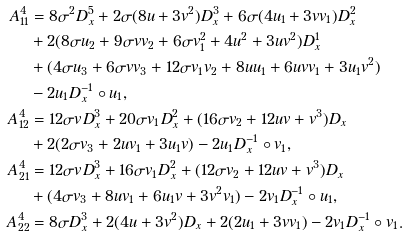<formula> <loc_0><loc_0><loc_500><loc_500>A ^ { 4 } _ { 1 1 } & = 8 \sigma ^ { 2 } D _ { x } ^ { 5 } + 2 \sigma ( 8 u + 3 v ^ { 2 } ) D _ { x } ^ { 3 } + 6 \sigma ( 4 u _ { 1 } + 3 v v _ { 1 } ) D _ { x } ^ { 2 } \\ & + 2 ( 8 \sigma u _ { 2 } + 9 \sigma v v _ { 2 } + 6 \sigma v _ { 1 } ^ { 2 } + 4 u ^ { 2 } + 3 u v ^ { 2 } ) D _ { x } ^ { 1 } \\ & + ( 4 \sigma u _ { 3 } + 6 \sigma v v _ { 3 } + 1 2 \sigma v _ { 1 } v _ { 2 } + 8 u u _ { 1 } + 6 u v v _ { 1 } + 3 u _ { 1 } v ^ { 2 } ) \\ & - 2 u _ { 1 } D _ { x } ^ { - 1 } \circ u _ { 1 } , \\ A ^ { 4 } _ { 1 2 } & = 1 2 \sigma v D _ { x } ^ { 3 } + 2 0 \sigma v _ { 1 } D _ { x } ^ { 2 } + ( 1 6 \sigma v _ { 2 } + 1 2 u v + v ^ { 3 } ) D _ { x } \\ & + 2 ( 2 \sigma v _ { 3 } + 2 u v _ { 1 } + 3 u _ { 1 } v ) - 2 u _ { 1 } D _ { x } ^ { - 1 } \circ v _ { 1 } , \\ A ^ { 4 } _ { 2 1 } & = 1 2 \sigma v D _ { x } ^ { 3 } + 1 6 \sigma v _ { 1 } D _ { x } ^ { 2 } + ( 1 2 \sigma v _ { 2 } + 1 2 u v + v ^ { 3 } ) D _ { x } \\ & + ( 4 \sigma v _ { 3 } + 8 u v _ { 1 } + 6 u _ { 1 } v + 3 v ^ { 2 } v _ { 1 } ) - 2 v _ { 1 } D _ { x } ^ { - 1 } \circ u _ { 1 } , \\ A ^ { 4 } _ { 2 2 } & = 8 \sigma D _ { x } ^ { 3 } + 2 ( 4 u + 3 v ^ { 2 } ) D _ { x } + 2 ( 2 u _ { 1 } + 3 v v _ { 1 } ) - 2 v _ { 1 } D _ { x } ^ { - 1 } \circ v _ { 1 } .</formula> 